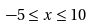<formula> <loc_0><loc_0><loc_500><loc_500>- 5 \leq x \leq 1 0</formula> 